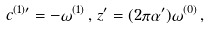Convert formula to latex. <formula><loc_0><loc_0><loc_500><loc_500>c ^ { ( 1 ) \prime } = - \omega ^ { ( 1 ) } \, , \, z ^ { \prime } = ( 2 \pi \alpha ^ { \prime } ) \omega ^ { ( 0 ) } \, ,</formula> 